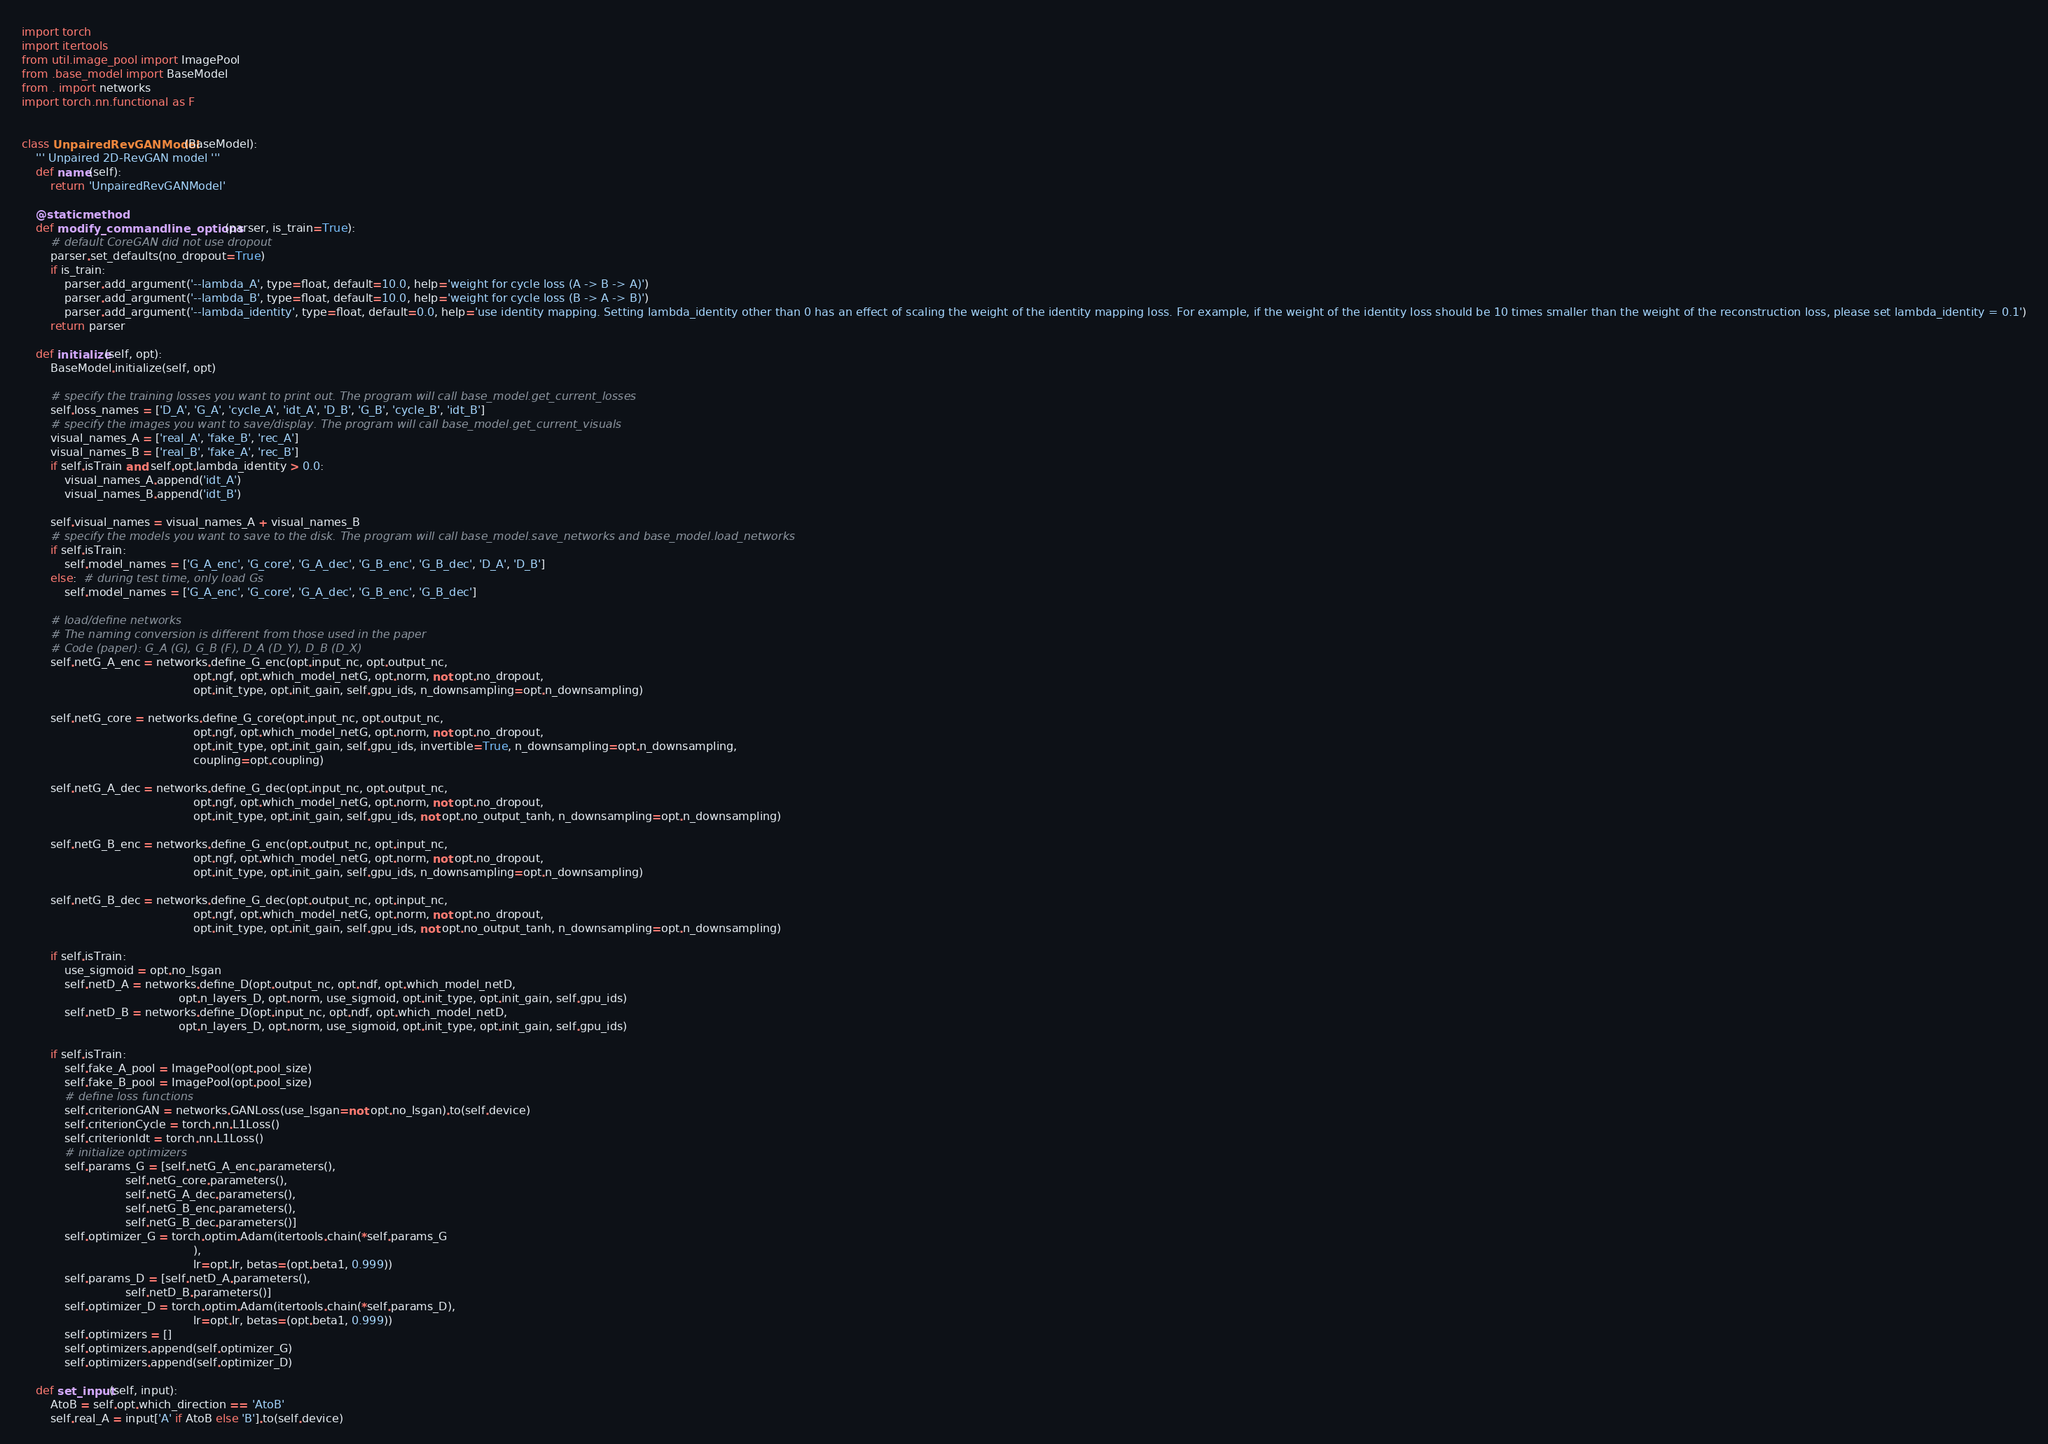Convert code to text. <code><loc_0><loc_0><loc_500><loc_500><_Python_>import torch
import itertools
from util.image_pool import ImagePool
from .base_model import BaseModel
from . import networks
import torch.nn.functional as F


class UnpairedRevGANModel(BaseModel):
    ''' Unpaired 2D-RevGAN model '''
    def name(self):
        return 'UnpairedRevGANModel'

    @staticmethod
    def modify_commandline_options(parser, is_train=True):
        # default CoreGAN did not use dropout
        parser.set_defaults(no_dropout=True)
        if is_train:
            parser.add_argument('--lambda_A', type=float, default=10.0, help='weight for cycle loss (A -> B -> A)')
            parser.add_argument('--lambda_B', type=float, default=10.0, help='weight for cycle loss (B -> A -> B)')
            parser.add_argument('--lambda_identity', type=float, default=0.0, help='use identity mapping. Setting lambda_identity other than 0 has an effect of scaling the weight of the identity mapping loss. For example, if the weight of the identity loss should be 10 times smaller than the weight of the reconstruction loss, please set lambda_identity = 0.1')
        return parser

    def initialize(self, opt):
        BaseModel.initialize(self, opt)

        # specify the training losses you want to print out. The program will call base_model.get_current_losses
        self.loss_names = ['D_A', 'G_A', 'cycle_A', 'idt_A', 'D_B', 'G_B', 'cycle_B', 'idt_B']
        # specify the images you want to save/display. The program will call base_model.get_current_visuals
        visual_names_A = ['real_A', 'fake_B', 'rec_A']
        visual_names_B = ['real_B', 'fake_A', 'rec_B']
        if self.isTrain and self.opt.lambda_identity > 0.0:
            visual_names_A.append('idt_A')
            visual_names_B.append('idt_B')

        self.visual_names = visual_names_A + visual_names_B
        # specify the models you want to save to the disk. The program will call base_model.save_networks and base_model.load_networks
        if self.isTrain:
            self.model_names = ['G_A_enc', 'G_core', 'G_A_dec', 'G_B_enc', 'G_B_dec', 'D_A', 'D_B']
        else:  # during test time, only load Gs
            self.model_names = ['G_A_enc', 'G_core', 'G_A_dec', 'G_B_enc', 'G_B_dec']

        # load/define networks
        # The naming conversion is different from those used in the paper
        # Code (paper): G_A (G), G_B (F), D_A (D_Y), D_B (D_X)
        self.netG_A_enc = networks.define_G_enc(opt.input_nc, opt.output_nc,
                                                opt.ngf, opt.which_model_netG, opt.norm, not opt.no_dropout,
                                                opt.init_type, opt.init_gain, self.gpu_ids, n_downsampling=opt.n_downsampling)

        self.netG_core = networks.define_G_core(opt.input_nc, opt.output_nc,
                                                opt.ngf, opt.which_model_netG, opt.norm, not opt.no_dropout,
                                                opt.init_type, opt.init_gain, self.gpu_ids, invertible=True, n_downsampling=opt.n_downsampling,
                                                coupling=opt.coupling)

        self.netG_A_dec = networks.define_G_dec(opt.input_nc, opt.output_nc,
                                                opt.ngf, opt.which_model_netG, opt.norm, not opt.no_dropout,
                                                opt.init_type, opt.init_gain, self.gpu_ids, not opt.no_output_tanh, n_downsampling=opt.n_downsampling)

        self.netG_B_enc = networks.define_G_enc(opt.output_nc, opt.input_nc,
                                                opt.ngf, opt.which_model_netG, opt.norm, not opt.no_dropout,
                                                opt.init_type, opt.init_gain, self.gpu_ids, n_downsampling=opt.n_downsampling)

        self.netG_B_dec = networks.define_G_dec(opt.output_nc, opt.input_nc,
                                                opt.ngf, opt.which_model_netG, opt.norm, not opt.no_dropout,
                                                opt.init_type, opt.init_gain, self.gpu_ids, not opt.no_output_tanh, n_downsampling=opt.n_downsampling)

        if self.isTrain:
            use_sigmoid = opt.no_lsgan
            self.netD_A = networks.define_D(opt.output_nc, opt.ndf, opt.which_model_netD,
                                            opt.n_layers_D, opt.norm, use_sigmoid, opt.init_type, opt.init_gain, self.gpu_ids)
            self.netD_B = networks.define_D(opt.input_nc, opt.ndf, opt.which_model_netD,
                                            opt.n_layers_D, opt.norm, use_sigmoid, opt.init_type, opt.init_gain, self.gpu_ids)

        if self.isTrain:
            self.fake_A_pool = ImagePool(opt.pool_size)
            self.fake_B_pool = ImagePool(opt.pool_size)
            # define loss functions
            self.criterionGAN = networks.GANLoss(use_lsgan=not opt.no_lsgan).to(self.device)
            self.criterionCycle = torch.nn.L1Loss()
            self.criterionIdt = torch.nn.L1Loss()
            # initialize optimizers
            self.params_G = [self.netG_A_enc.parameters(),
                             self.netG_core.parameters(),
                             self.netG_A_dec.parameters(),
                             self.netG_B_enc.parameters(),
                             self.netG_B_dec.parameters()]
            self.optimizer_G = torch.optim.Adam(itertools.chain(*self.params_G
                                                ),
                                                lr=opt.lr, betas=(opt.beta1, 0.999))
            self.params_D = [self.netD_A.parameters(),
                             self.netD_B.parameters()]
            self.optimizer_D = torch.optim.Adam(itertools.chain(*self.params_D),
                                                lr=opt.lr, betas=(opt.beta1, 0.999))
            self.optimizers = []
            self.optimizers.append(self.optimizer_G)
            self.optimizers.append(self.optimizer_D)

    def set_input(self, input):
        AtoB = self.opt.which_direction == 'AtoB'
        self.real_A = input['A' if AtoB else 'B'].to(self.device)</code> 